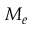Convert formula to latex. <formula><loc_0><loc_0><loc_500><loc_500>M _ { e }</formula> 